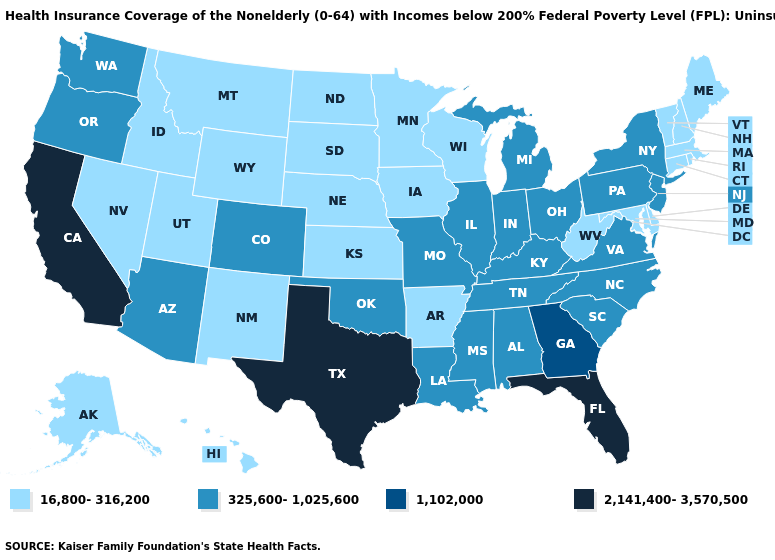Name the states that have a value in the range 2,141,400-3,570,500?
Answer briefly. California, Florida, Texas. What is the highest value in states that border Florida?
Quick response, please. 1,102,000. What is the lowest value in the Northeast?
Quick response, please. 16,800-316,200. Name the states that have a value in the range 325,600-1,025,600?
Be succinct. Alabama, Arizona, Colorado, Illinois, Indiana, Kentucky, Louisiana, Michigan, Mississippi, Missouri, New Jersey, New York, North Carolina, Ohio, Oklahoma, Oregon, Pennsylvania, South Carolina, Tennessee, Virginia, Washington. Among the states that border Nebraska , does Missouri have the highest value?
Write a very short answer. Yes. Among the states that border Alabama , which have the lowest value?
Give a very brief answer. Mississippi, Tennessee. Is the legend a continuous bar?
Quick response, please. No. Does the map have missing data?
Concise answer only. No. Does Indiana have the highest value in the USA?
Quick response, please. No. Name the states that have a value in the range 16,800-316,200?
Concise answer only. Alaska, Arkansas, Connecticut, Delaware, Hawaii, Idaho, Iowa, Kansas, Maine, Maryland, Massachusetts, Minnesota, Montana, Nebraska, Nevada, New Hampshire, New Mexico, North Dakota, Rhode Island, South Dakota, Utah, Vermont, West Virginia, Wisconsin, Wyoming. Does South Carolina have the lowest value in the USA?
Give a very brief answer. No. What is the value of Kansas?
Quick response, please. 16,800-316,200. Is the legend a continuous bar?
Give a very brief answer. No. Among the states that border Massachusetts , which have the highest value?
Keep it brief. New York. Name the states that have a value in the range 1,102,000?
Quick response, please. Georgia. 